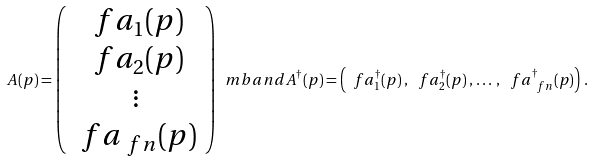Convert formula to latex. <formula><loc_0><loc_0><loc_500><loc_500>A ( p ) = \left ( \begin{array} { c } \ f a _ { 1 } ( p ) \\ \ f a _ { 2 } ( p ) \\ \vdots \\ \ f a _ { \ f n } ( p ) \end{array} \right ) \ m b { a n d } A ^ { \dag } ( p ) = \left ( \ f a ^ { \dag } _ { 1 } ( p ) \, , \, \ f a ^ { \dag } _ { 2 } ( p ) \, , \, \dots \, , \, \ f a ^ { \dag } _ { \ f n } ( p ) \right ) \, .</formula> 